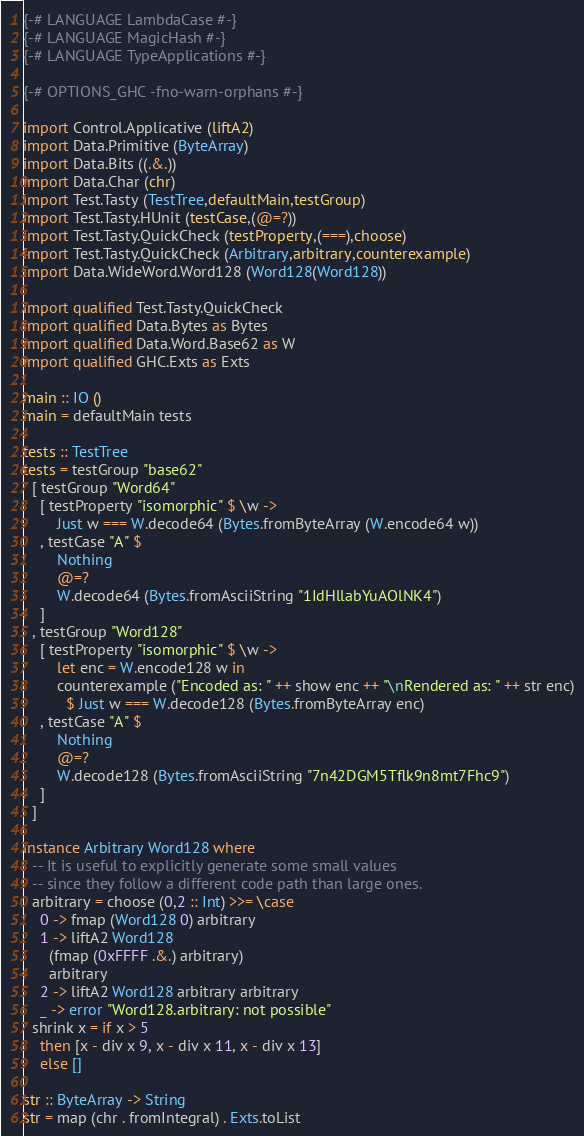Convert code to text. <code><loc_0><loc_0><loc_500><loc_500><_Haskell_>{-# LANGUAGE LambdaCase #-}
{-# LANGUAGE MagicHash #-}
{-# LANGUAGE TypeApplications #-}

{-# OPTIONS_GHC -fno-warn-orphans #-}

import Control.Applicative (liftA2)
import Data.Primitive (ByteArray)
import Data.Bits ((.&.))
import Data.Char (chr)
import Test.Tasty (TestTree,defaultMain,testGroup)
import Test.Tasty.HUnit (testCase,(@=?))
import Test.Tasty.QuickCheck (testProperty,(===),choose)
import Test.Tasty.QuickCheck (Arbitrary,arbitrary,counterexample)
import Data.WideWord.Word128 (Word128(Word128))

import qualified Test.Tasty.QuickCheck
import qualified Data.Bytes as Bytes
import qualified Data.Word.Base62 as W
import qualified GHC.Exts as Exts

main :: IO ()
main = defaultMain tests

tests :: TestTree
tests = testGroup "base62"
  [ testGroup "Word64"
    [ testProperty "isomorphic" $ \w ->
        Just w === W.decode64 (Bytes.fromByteArray (W.encode64 w))
    , testCase "A" $
        Nothing
        @=?
        W.decode64 (Bytes.fromAsciiString "1IdHllabYuAOlNK4")
    ]
  , testGroup "Word128"
    [ testProperty "isomorphic" $ \w ->
        let enc = W.encode128 w in
        counterexample ("Encoded as: " ++ show enc ++ "\nRendered as: " ++ str enc)
          $ Just w === W.decode128 (Bytes.fromByteArray enc)
    , testCase "A" $
        Nothing
        @=?
        W.decode128 (Bytes.fromAsciiString "7n42DGM5Tflk9n8mt7Fhc9")
    ]
  ]

instance Arbitrary Word128 where
  -- It is useful to explicitly generate some small values
  -- since they follow a different code path than large ones.
  arbitrary = choose (0,2 :: Int) >>= \case
    0 -> fmap (Word128 0) arbitrary
    1 -> liftA2 Word128
      (fmap (0xFFFF .&.) arbitrary)
      arbitrary
    2 -> liftA2 Word128 arbitrary arbitrary
    _ -> error "Word128.arbitrary: not possible"
  shrink x = if x > 5
    then [x - div x 9, x - div x 11, x - div x 13]
    else []

str :: ByteArray -> String
str = map (chr . fromIntegral) . Exts.toList
</code> 